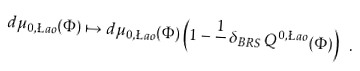Convert formula to latex. <formula><loc_0><loc_0><loc_500><loc_500>d \mu _ { 0 , \L a o } ( \Phi ) \mapsto d \mu _ { 0 , \L a o } ( \Phi ) \left ( 1 - \frac { 1 } { } \, \delta _ { B R S } \, Q ^ { 0 , \L a o } ( \Phi ) \right ) \ .</formula> 